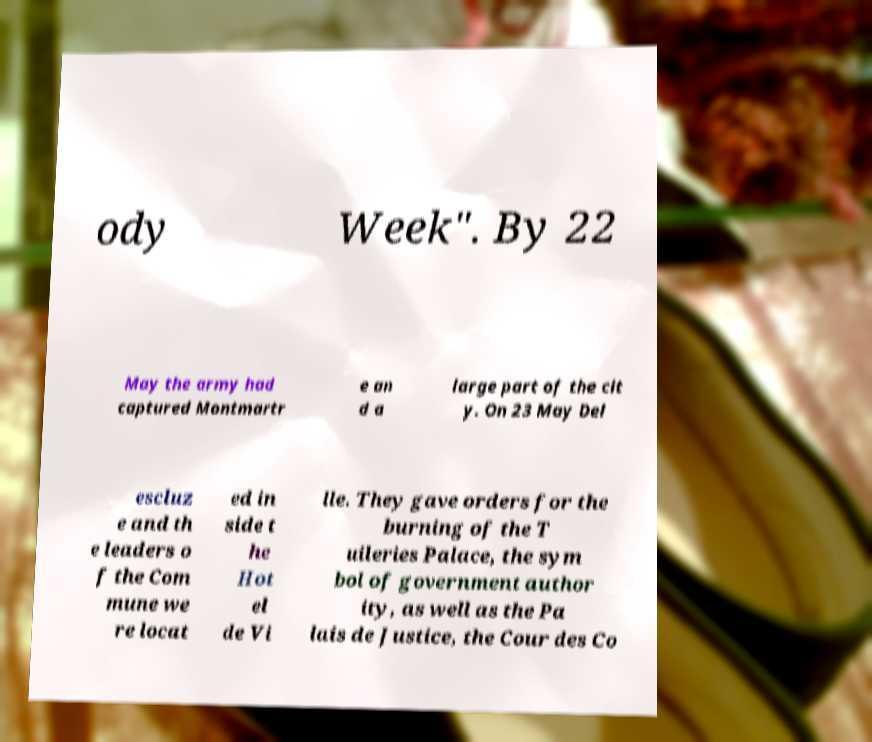Could you assist in decoding the text presented in this image and type it out clearly? ody Week". By 22 May the army had captured Montmartr e an d a large part of the cit y. On 23 May Del escluz e and th e leaders o f the Com mune we re locat ed in side t he Hot el de Vi lle. They gave orders for the burning of the T uileries Palace, the sym bol of government author ity, as well as the Pa lais de Justice, the Cour des Co 